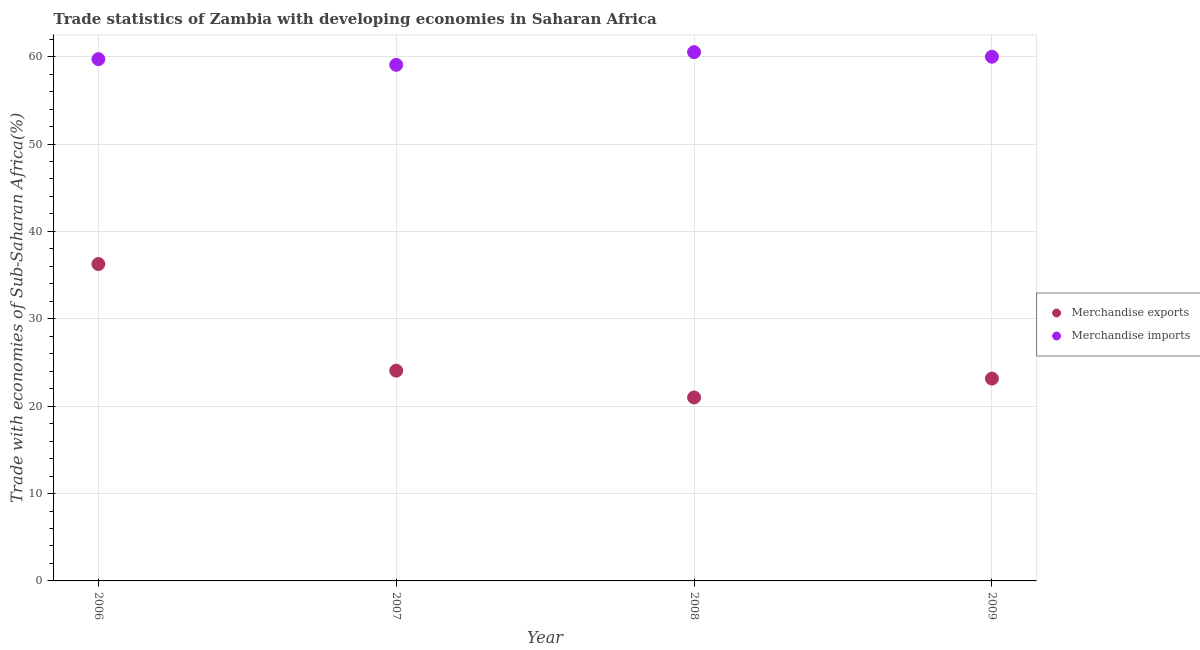How many different coloured dotlines are there?
Keep it short and to the point. 2. What is the merchandise imports in 2007?
Provide a succinct answer. 59.07. Across all years, what is the maximum merchandise exports?
Offer a very short reply. 36.27. Across all years, what is the minimum merchandise exports?
Keep it short and to the point. 20.99. What is the total merchandise imports in the graph?
Keep it short and to the point. 239.3. What is the difference between the merchandise imports in 2006 and that in 2008?
Provide a succinct answer. -0.8. What is the difference between the merchandise exports in 2006 and the merchandise imports in 2008?
Give a very brief answer. -24.25. What is the average merchandise exports per year?
Ensure brevity in your answer.  26.12. In the year 2007, what is the difference between the merchandise imports and merchandise exports?
Keep it short and to the point. 35. In how many years, is the merchandise imports greater than 12 %?
Make the answer very short. 4. What is the ratio of the merchandise exports in 2006 to that in 2009?
Provide a succinct answer. 1.57. Is the merchandise imports in 2006 less than that in 2008?
Offer a terse response. Yes. Is the difference between the merchandise exports in 2007 and 2008 greater than the difference between the merchandise imports in 2007 and 2008?
Offer a very short reply. Yes. What is the difference between the highest and the second highest merchandise exports?
Offer a very short reply. 12.2. What is the difference between the highest and the lowest merchandise exports?
Offer a terse response. 15.27. Is the sum of the merchandise imports in 2007 and 2008 greater than the maximum merchandise exports across all years?
Your response must be concise. Yes. Is the merchandise exports strictly less than the merchandise imports over the years?
Offer a very short reply. Yes. How many years are there in the graph?
Offer a terse response. 4. What is the difference between two consecutive major ticks on the Y-axis?
Make the answer very short. 10. Does the graph contain any zero values?
Ensure brevity in your answer.  No. Does the graph contain grids?
Your answer should be very brief. Yes. What is the title of the graph?
Your answer should be compact. Trade statistics of Zambia with developing economies in Saharan Africa. Does "Nitrous oxide" appear as one of the legend labels in the graph?
Make the answer very short. No. What is the label or title of the Y-axis?
Keep it short and to the point. Trade with economies of Sub-Saharan Africa(%). What is the Trade with economies of Sub-Saharan Africa(%) of Merchandise exports in 2006?
Make the answer very short. 36.27. What is the Trade with economies of Sub-Saharan Africa(%) in Merchandise imports in 2006?
Offer a very short reply. 59.72. What is the Trade with economies of Sub-Saharan Africa(%) of Merchandise exports in 2007?
Keep it short and to the point. 24.06. What is the Trade with economies of Sub-Saharan Africa(%) in Merchandise imports in 2007?
Make the answer very short. 59.07. What is the Trade with economies of Sub-Saharan Africa(%) of Merchandise exports in 2008?
Provide a succinct answer. 20.99. What is the Trade with economies of Sub-Saharan Africa(%) in Merchandise imports in 2008?
Provide a succinct answer. 60.52. What is the Trade with economies of Sub-Saharan Africa(%) of Merchandise exports in 2009?
Keep it short and to the point. 23.16. What is the Trade with economies of Sub-Saharan Africa(%) of Merchandise imports in 2009?
Make the answer very short. 59.99. Across all years, what is the maximum Trade with economies of Sub-Saharan Africa(%) of Merchandise exports?
Give a very brief answer. 36.27. Across all years, what is the maximum Trade with economies of Sub-Saharan Africa(%) of Merchandise imports?
Offer a very short reply. 60.52. Across all years, what is the minimum Trade with economies of Sub-Saharan Africa(%) of Merchandise exports?
Offer a terse response. 20.99. Across all years, what is the minimum Trade with economies of Sub-Saharan Africa(%) in Merchandise imports?
Provide a short and direct response. 59.07. What is the total Trade with economies of Sub-Saharan Africa(%) in Merchandise exports in the graph?
Provide a short and direct response. 104.48. What is the total Trade with economies of Sub-Saharan Africa(%) of Merchandise imports in the graph?
Make the answer very short. 239.3. What is the difference between the Trade with economies of Sub-Saharan Africa(%) in Merchandise exports in 2006 and that in 2007?
Provide a short and direct response. 12.2. What is the difference between the Trade with economies of Sub-Saharan Africa(%) in Merchandise imports in 2006 and that in 2007?
Provide a succinct answer. 0.65. What is the difference between the Trade with economies of Sub-Saharan Africa(%) of Merchandise exports in 2006 and that in 2008?
Your response must be concise. 15.27. What is the difference between the Trade with economies of Sub-Saharan Africa(%) in Merchandise imports in 2006 and that in 2008?
Give a very brief answer. -0.8. What is the difference between the Trade with economies of Sub-Saharan Africa(%) in Merchandise exports in 2006 and that in 2009?
Make the answer very short. 13.11. What is the difference between the Trade with economies of Sub-Saharan Africa(%) in Merchandise imports in 2006 and that in 2009?
Provide a short and direct response. -0.28. What is the difference between the Trade with economies of Sub-Saharan Africa(%) of Merchandise exports in 2007 and that in 2008?
Provide a succinct answer. 3.07. What is the difference between the Trade with economies of Sub-Saharan Africa(%) of Merchandise imports in 2007 and that in 2008?
Offer a very short reply. -1.45. What is the difference between the Trade with economies of Sub-Saharan Africa(%) of Merchandise exports in 2007 and that in 2009?
Ensure brevity in your answer.  0.91. What is the difference between the Trade with economies of Sub-Saharan Africa(%) of Merchandise imports in 2007 and that in 2009?
Give a very brief answer. -0.93. What is the difference between the Trade with economies of Sub-Saharan Africa(%) of Merchandise exports in 2008 and that in 2009?
Give a very brief answer. -2.16. What is the difference between the Trade with economies of Sub-Saharan Africa(%) in Merchandise imports in 2008 and that in 2009?
Keep it short and to the point. 0.52. What is the difference between the Trade with economies of Sub-Saharan Africa(%) in Merchandise exports in 2006 and the Trade with economies of Sub-Saharan Africa(%) in Merchandise imports in 2007?
Provide a short and direct response. -22.8. What is the difference between the Trade with economies of Sub-Saharan Africa(%) of Merchandise exports in 2006 and the Trade with economies of Sub-Saharan Africa(%) of Merchandise imports in 2008?
Provide a short and direct response. -24.25. What is the difference between the Trade with economies of Sub-Saharan Africa(%) of Merchandise exports in 2006 and the Trade with economies of Sub-Saharan Africa(%) of Merchandise imports in 2009?
Provide a succinct answer. -23.73. What is the difference between the Trade with economies of Sub-Saharan Africa(%) in Merchandise exports in 2007 and the Trade with economies of Sub-Saharan Africa(%) in Merchandise imports in 2008?
Your answer should be very brief. -36.45. What is the difference between the Trade with economies of Sub-Saharan Africa(%) of Merchandise exports in 2007 and the Trade with economies of Sub-Saharan Africa(%) of Merchandise imports in 2009?
Make the answer very short. -35.93. What is the difference between the Trade with economies of Sub-Saharan Africa(%) in Merchandise exports in 2008 and the Trade with economies of Sub-Saharan Africa(%) in Merchandise imports in 2009?
Keep it short and to the point. -39. What is the average Trade with economies of Sub-Saharan Africa(%) of Merchandise exports per year?
Your answer should be compact. 26.12. What is the average Trade with economies of Sub-Saharan Africa(%) in Merchandise imports per year?
Your answer should be very brief. 59.82. In the year 2006, what is the difference between the Trade with economies of Sub-Saharan Africa(%) in Merchandise exports and Trade with economies of Sub-Saharan Africa(%) in Merchandise imports?
Provide a succinct answer. -23.45. In the year 2007, what is the difference between the Trade with economies of Sub-Saharan Africa(%) of Merchandise exports and Trade with economies of Sub-Saharan Africa(%) of Merchandise imports?
Offer a very short reply. -35. In the year 2008, what is the difference between the Trade with economies of Sub-Saharan Africa(%) of Merchandise exports and Trade with economies of Sub-Saharan Africa(%) of Merchandise imports?
Ensure brevity in your answer.  -39.52. In the year 2009, what is the difference between the Trade with economies of Sub-Saharan Africa(%) in Merchandise exports and Trade with economies of Sub-Saharan Africa(%) in Merchandise imports?
Provide a succinct answer. -36.84. What is the ratio of the Trade with economies of Sub-Saharan Africa(%) of Merchandise exports in 2006 to that in 2007?
Keep it short and to the point. 1.51. What is the ratio of the Trade with economies of Sub-Saharan Africa(%) of Merchandise exports in 2006 to that in 2008?
Your answer should be very brief. 1.73. What is the ratio of the Trade with economies of Sub-Saharan Africa(%) in Merchandise imports in 2006 to that in 2008?
Make the answer very short. 0.99. What is the ratio of the Trade with economies of Sub-Saharan Africa(%) in Merchandise exports in 2006 to that in 2009?
Your answer should be very brief. 1.57. What is the ratio of the Trade with economies of Sub-Saharan Africa(%) in Merchandise exports in 2007 to that in 2008?
Make the answer very short. 1.15. What is the ratio of the Trade with economies of Sub-Saharan Africa(%) in Merchandise exports in 2007 to that in 2009?
Your answer should be very brief. 1.04. What is the ratio of the Trade with economies of Sub-Saharan Africa(%) in Merchandise imports in 2007 to that in 2009?
Give a very brief answer. 0.98. What is the ratio of the Trade with economies of Sub-Saharan Africa(%) in Merchandise exports in 2008 to that in 2009?
Keep it short and to the point. 0.91. What is the ratio of the Trade with economies of Sub-Saharan Africa(%) of Merchandise imports in 2008 to that in 2009?
Provide a short and direct response. 1.01. What is the difference between the highest and the second highest Trade with economies of Sub-Saharan Africa(%) in Merchandise exports?
Your response must be concise. 12.2. What is the difference between the highest and the second highest Trade with economies of Sub-Saharan Africa(%) in Merchandise imports?
Give a very brief answer. 0.52. What is the difference between the highest and the lowest Trade with economies of Sub-Saharan Africa(%) in Merchandise exports?
Give a very brief answer. 15.27. What is the difference between the highest and the lowest Trade with economies of Sub-Saharan Africa(%) in Merchandise imports?
Your answer should be very brief. 1.45. 